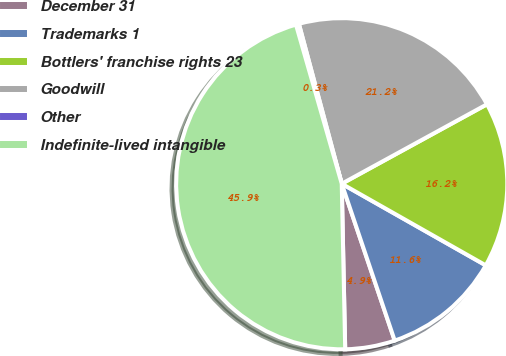Convert chart. <chart><loc_0><loc_0><loc_500><loc_500><pie_chart><fcel>December 31<fcel>Trademarks 1<fcel>Bottlers' franchise rights 23<fcel>Goodwill<fcel>Other<fcel>Indefinite-lived intangible<nl><fcel>4.85%<fcel>11.61%<fcel>16.17%<fcel>21.2%<fcel>0.29%<fcel>45.87%<nl></chart> 